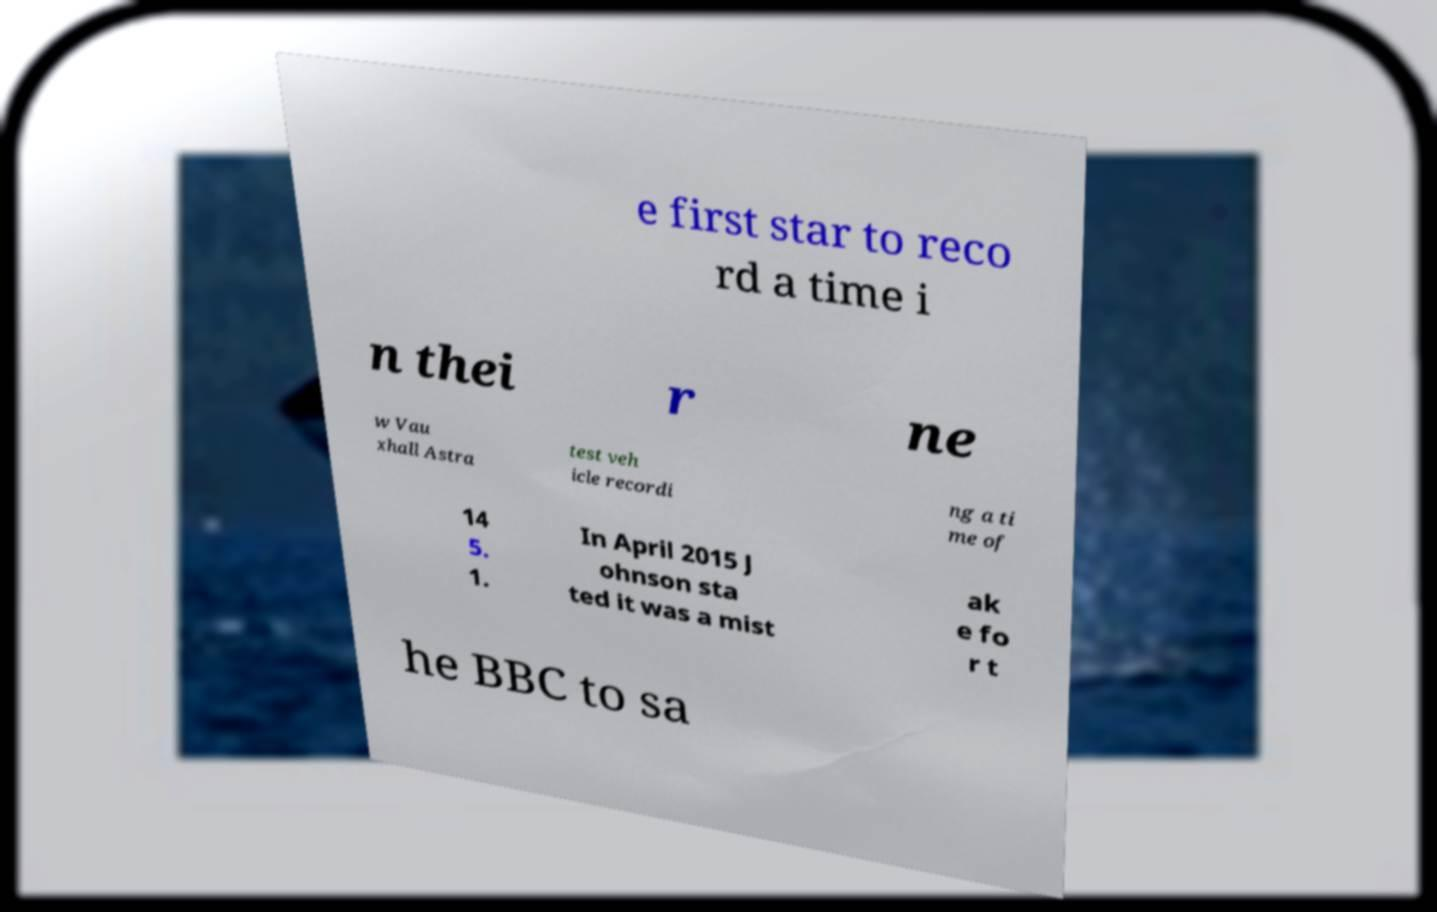Can you read and provide the text displayed in the image?This photo seems to have some interesting text. Can you extract and type it out for me? e first star to reco rd a time i n thei r ne w Vau xhall Astra test veh icle recordi ng a ti me of 14 5. 1. In April 2015 J ohnson sta ted it was a mist ak e fo r t he BBC to sa 